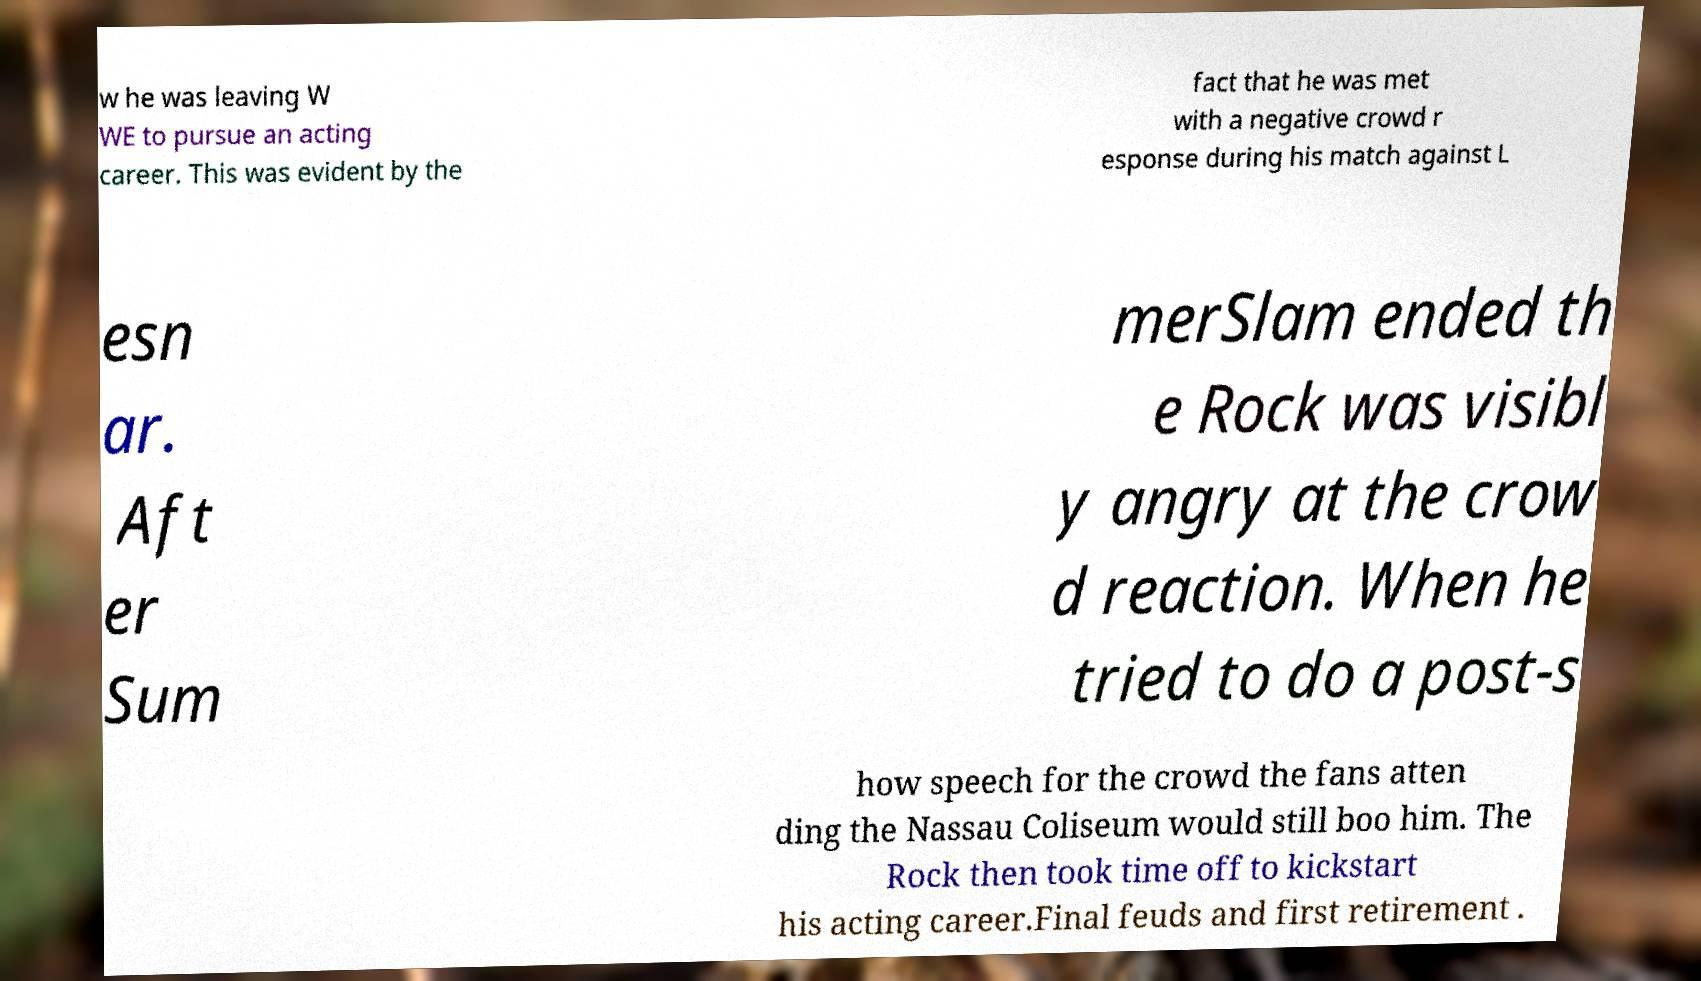Can you read and provide the text displayed in the image?This photo seems to have some interesting text. Can you extract and type it out for me? w he was leaving W WE to pursue an acting career. This was evident by the fact that he was met with a negative crowd r esponse during his match against L esn ar. Aft er Sum merSlam ended th e Rock was visibl y angry at the crow d reaction. When he tried to do a post-s how speech for the crowd the fans atten ding the Nassau Coliseum would still boo him. The Rock then took time off to kickstart his acting career.Final feuds and first retirement . 